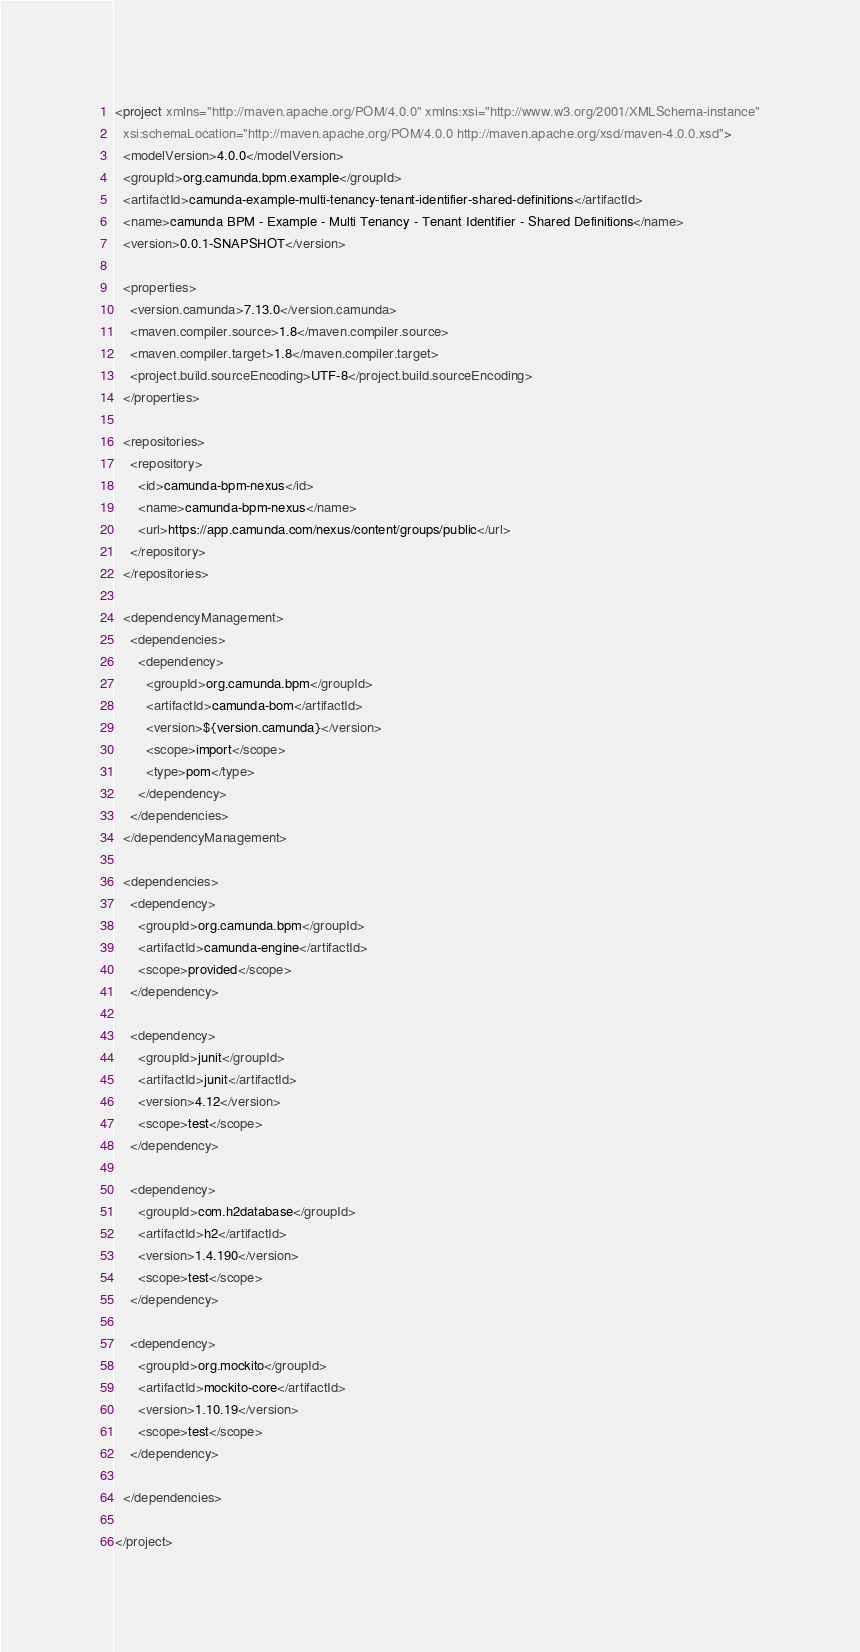<code> <loc_0><loc_0><loc_500><loc_500><_XML_><project xmlns="http://maven.apache.org/POM/4.0.0" xmlns:xsi="http://www.w3.org/2001/XMLSchema-instance"
  xsi:schemaLocation="http://maven.apache.org/POM/4.0.0 http://maven.apache.org/xsd/maven-4.0.0.xsd">
  <modelVersion>4.0.0</modelVersion>
  <groupId>org.camunda.bpm.example</groupId>
  <artifactId>camunda-example-multi-tenancy-tenant-identifier-shared-definitions</artifactId>
  <name>camunda BPM - Example - Multi Tenancy - Tenant Identifier - Shared Definitions</name>
  <version>0.0.1-SNAPSHOT</version>

  <properties>
    <version.camunda>7.13.0</version.camunda>
    <maven.compiler.source>1.8</maven.compiler.source>
    <maven.compiler.target>1.8</maven.compiler.target>
    <project.build.sourceEncoding>UTF-8</project.build.sourceEncoding>
  </properties>

  <repositories>
    <repository>
      <id>camunda-bpm-nexus</id>
      <name>camunda-bpm-nexus</name>
      <url>https://app.camunda.com/nexus/content/groups/public</url>
    </repository>
  </repositories>
  
  <dependencyManagement>
    <dependencies>
      <dependency>
        <groupId>org.camunda.bpm</groupId>
        <artifactId>camunda-bom</artifactId>
        <version>${version.camunda}</version>
        <scope>import</scope>
        <type>pom</type>
      </dependency>
    </dependencies>
  </dependencyManagement>
  
  <dependencies>
    <dependency>
      <groupId>org.camunda.bpm</groupId>
      <artifactId>camunda-engine</artifactId>
      <scope>provided</scope>
    </dependency>
    
    <dependency>
      <groupId>junit</groupId>
      <artifactId>junit</artifactId>
      <version>4.12</version>
      <scope>test</scope>
    </dependency>

    <dependency>
      <groupId>com.h2database</groupId>
      <artifactId>h2</artifactId>
      <version>1.4.190</version>
      <scope>test</scope>
    </dependency>

    <dependency>
      <groupId>org.mockito</groupId>
      <artifactId>mockito-core</artifactId>
      <version>1.10.19</version>
      <scope>test</scope>
    </dependency>
    
  </dependencies>
  
</project>
</code> 